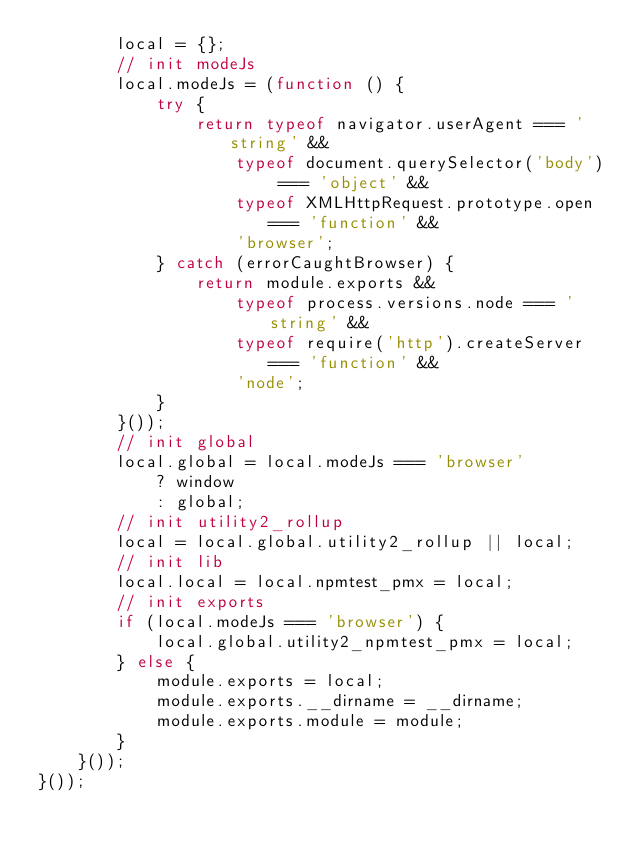<code> <loc_0><loc_0><loc_500><loc_500><_JavaScript_>        local = {};
        // init modeJs
        local.modeJs = (function () {
            try {
                return typeof navigator.userAgent === 'string' &&
                    typeof document.querySelector('body') === 'object' &&
                    typeof XMLHttpRequest.prototype.open === 'function' &&
                    'browser';
            } catch (errorCaughtBrowser) {
                return module.exports &&
                    typeof process.versions.node === 'string' &&
                    typeof require('http').createServer === 'function' &&
                    'node';
            }
        }());
        // init global
        local.global = local.modeJs === 'browser'
            ? window
            : global;
        // init utility2_rollup
        local = local.global.utility2_rollup || local;
        // init lib
        local.local = local.npmtest_pmx = local;
        // init exports
        if (local.modeJs === 'browser') {
            local.global.utility2_npmtest_pmx = local;
        } else {
            module.exports = local;
            module.exports.__dirname = __dirname;
            module.exports.module = module;
        }
    }());
}());
</code> 